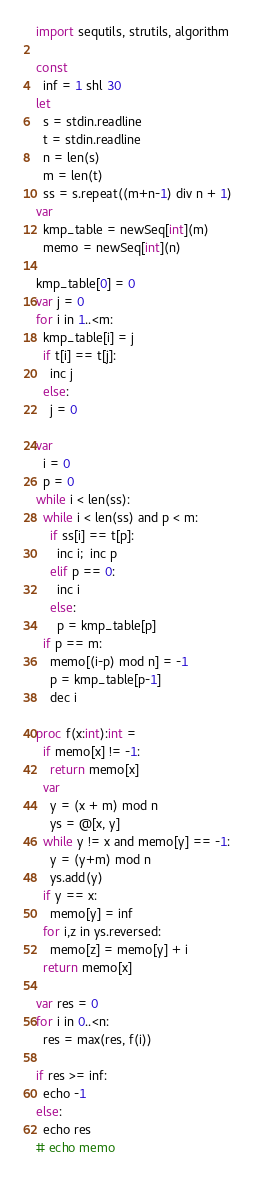Convert code to text. <code><loc_0><loc_0><loc_500><loc_500><_Nim_>import sequtils, strutils, algorithm

const
  inf = 1 shl 30
let
  s = stdin.readline
  t = stdin.readline
  n = len(s)
  m = len(t)
  ss = s.repeat((m+n-1) div n + 1)
var
  kmp_table = newSeq[int](m)
  memo = newSeq[int](n)

kmp_table[0] = 0
var j = 0
for i in 1..<m:
  kmp_table[i] = j
  if t[i] == t[j]:
    inc j
  else:
    j = 0

var
  i = 0
  p = 0
while i < len(ss):
  while i < len(ss) and p < m:
    if ss[i] == t[p]:
      inc i;  inc p
    elif p == 0:
      inc i
    else:
      p = kmp_table[p]
  if p == m:
    memo[(i-p) mod n] = -1
    p = kmp_table[p-1]
    dec i

proc f(x:int):int =
  if memo[x] != -1:
    return memo[x]
  var
    y = (x + m) mod n
    ys = @[x, y]
  while y != x and memo[y] == -1:
    y = (y+m) mod n
    ys.add(y)
  if y == x:
    memo[y] = inf
  for i,z in ys.reversed:
    memo[z] = memo[y] + i
  return memo[x]
  
var res = 0
for i in 0..<n:
  res = max(res, f(i))

if res >= inf:
  echo -1
else:
  echo res
# echo memo
</code> 